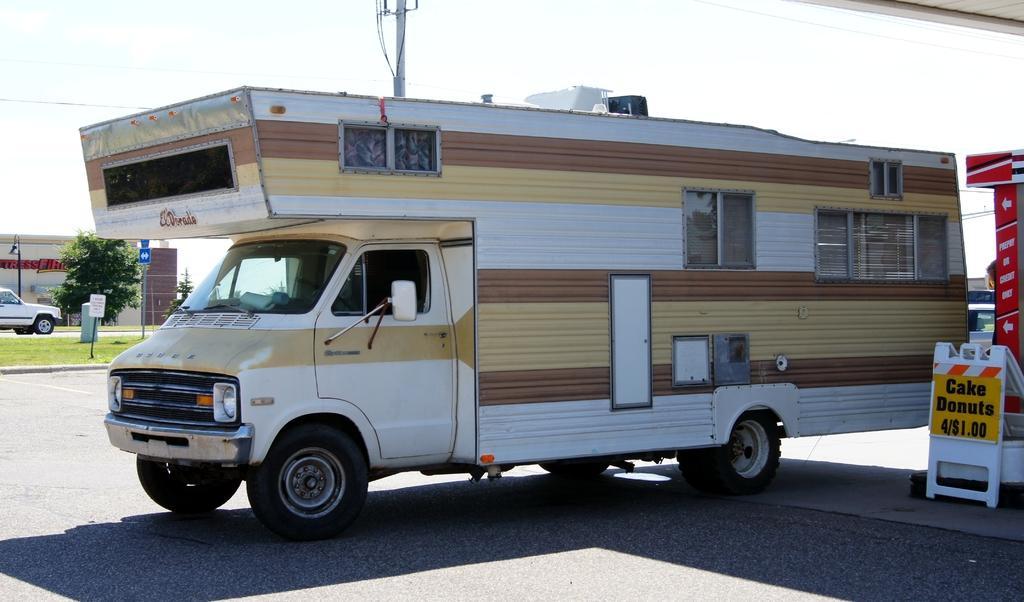Please provide a concise description of this image. In this picture we can observe a white, brown and cream color vehicle on this road. On the right side we can observe yellow and white color board. On the left side there is a tree and a car. In the background there is a pole and a sky. 